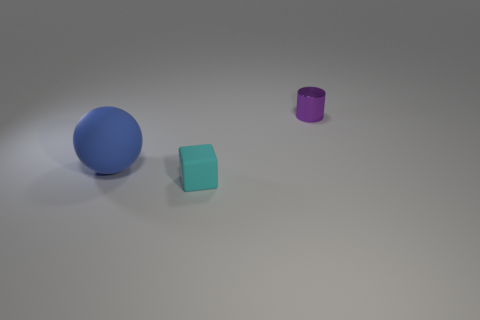Add 3 purple balls. How many objects exist? 6 Subtract all cubes. How many objects are left? 2 Add 2 small cyan objects. How many small cyan objects are left? 3 Add 3 blue cylinders. How many blue cylinders exist? 3 Subtract 0 green cylinders. How many objects are left? 3 Subtract all brown balls. Subtract all metallic objects. How many objects are left? 2 